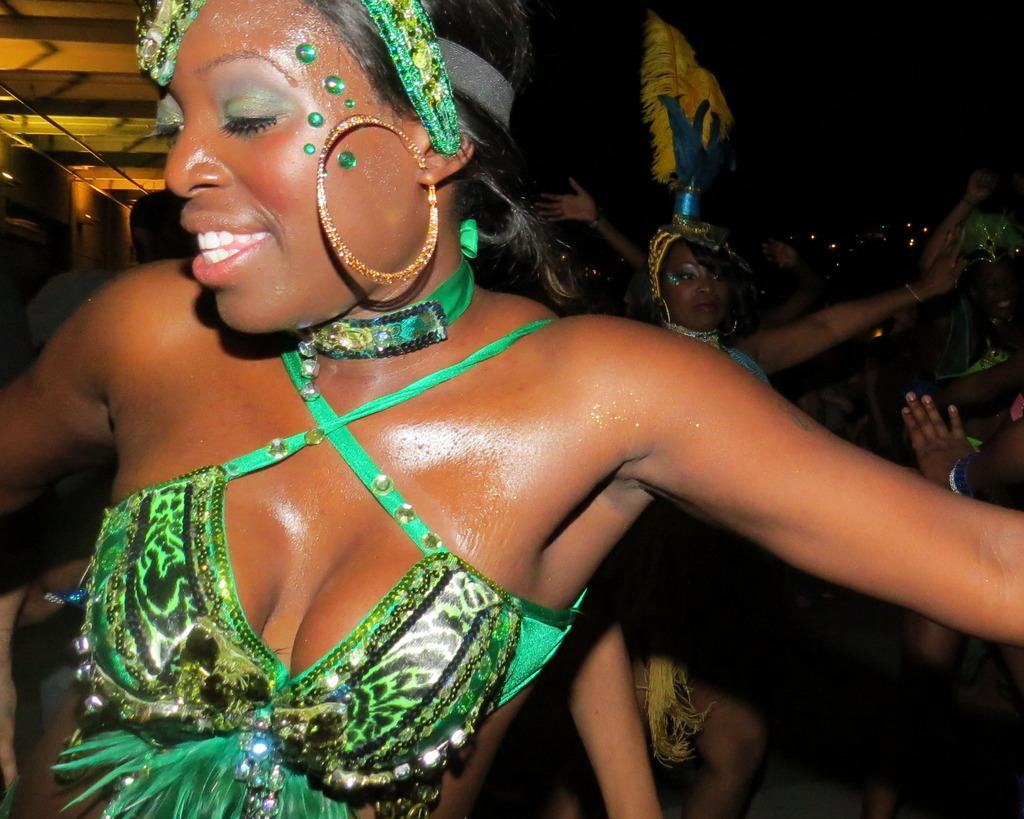What are the ladies in the image doing? The ladies are dancing in the image. What are the ladies wearing while dancing? The ladies are wearing costumes in the image. What can be seen in the background of the image? There is a building in the background of the image. How many cacti are present in the image? There are no cacti present in the image. What type of respect can be seen being shown between the ladies in the image? The image does not show any specific type of respect between the ladies; it only shows them dancing. 